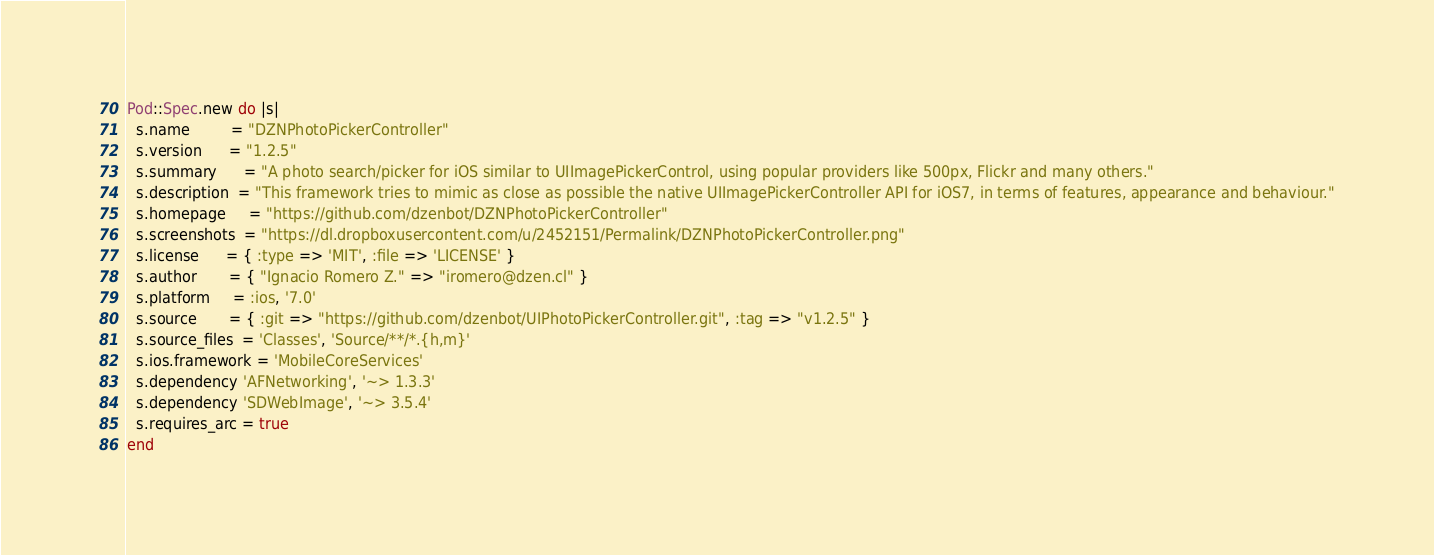Convert code to text. <code><loc_0><loc_0><loc_500><loc_500><_Ruby_>
Pod::Spec.new do |s|
  s.name         = "DZNPhotoPickerController"
  s.version      = "1.2.5"
  s.summary      = "A photo search/picker for iOS similar to UIImagePickerControl, using popular providers like 500px, Flickr and many others."
  s.description  = "This framework tries to mimic as close as possible the native UIImagePickerController API for iOS7, in terms of features, appearance and behaviour."
  s.homepage     = "https://github.com/dzenbot/DZNPhotoPickerController"
  s.screenshots  = "https://dl.dropboxusercontent.com/u/2452151/Permalink/DZNPhotoPickerController.png"
  s.license      = { :type => 'MIT', :file => 'LICENSE' }
  s.author       = { "Ignacio Romero Z." => "iromero@dzen.cl" }
  s.platform     = :ios, '7.0'
  s.source       = { :git => "https://github.com/dzenbot/UIPhotoPickerController.git", :tag => "v1.2.5" }
  s.source_files  = 'Classes', 'Source/**/*.{h,m}'
  s.ios.framework = 'MobileCoreServices'
  s.dependency 'AFNetworking', '~> 1.3.3'
  s.dependency 'SDWebImage', '~> 3.5.4'
  s.requires_arc = true
end</code> 